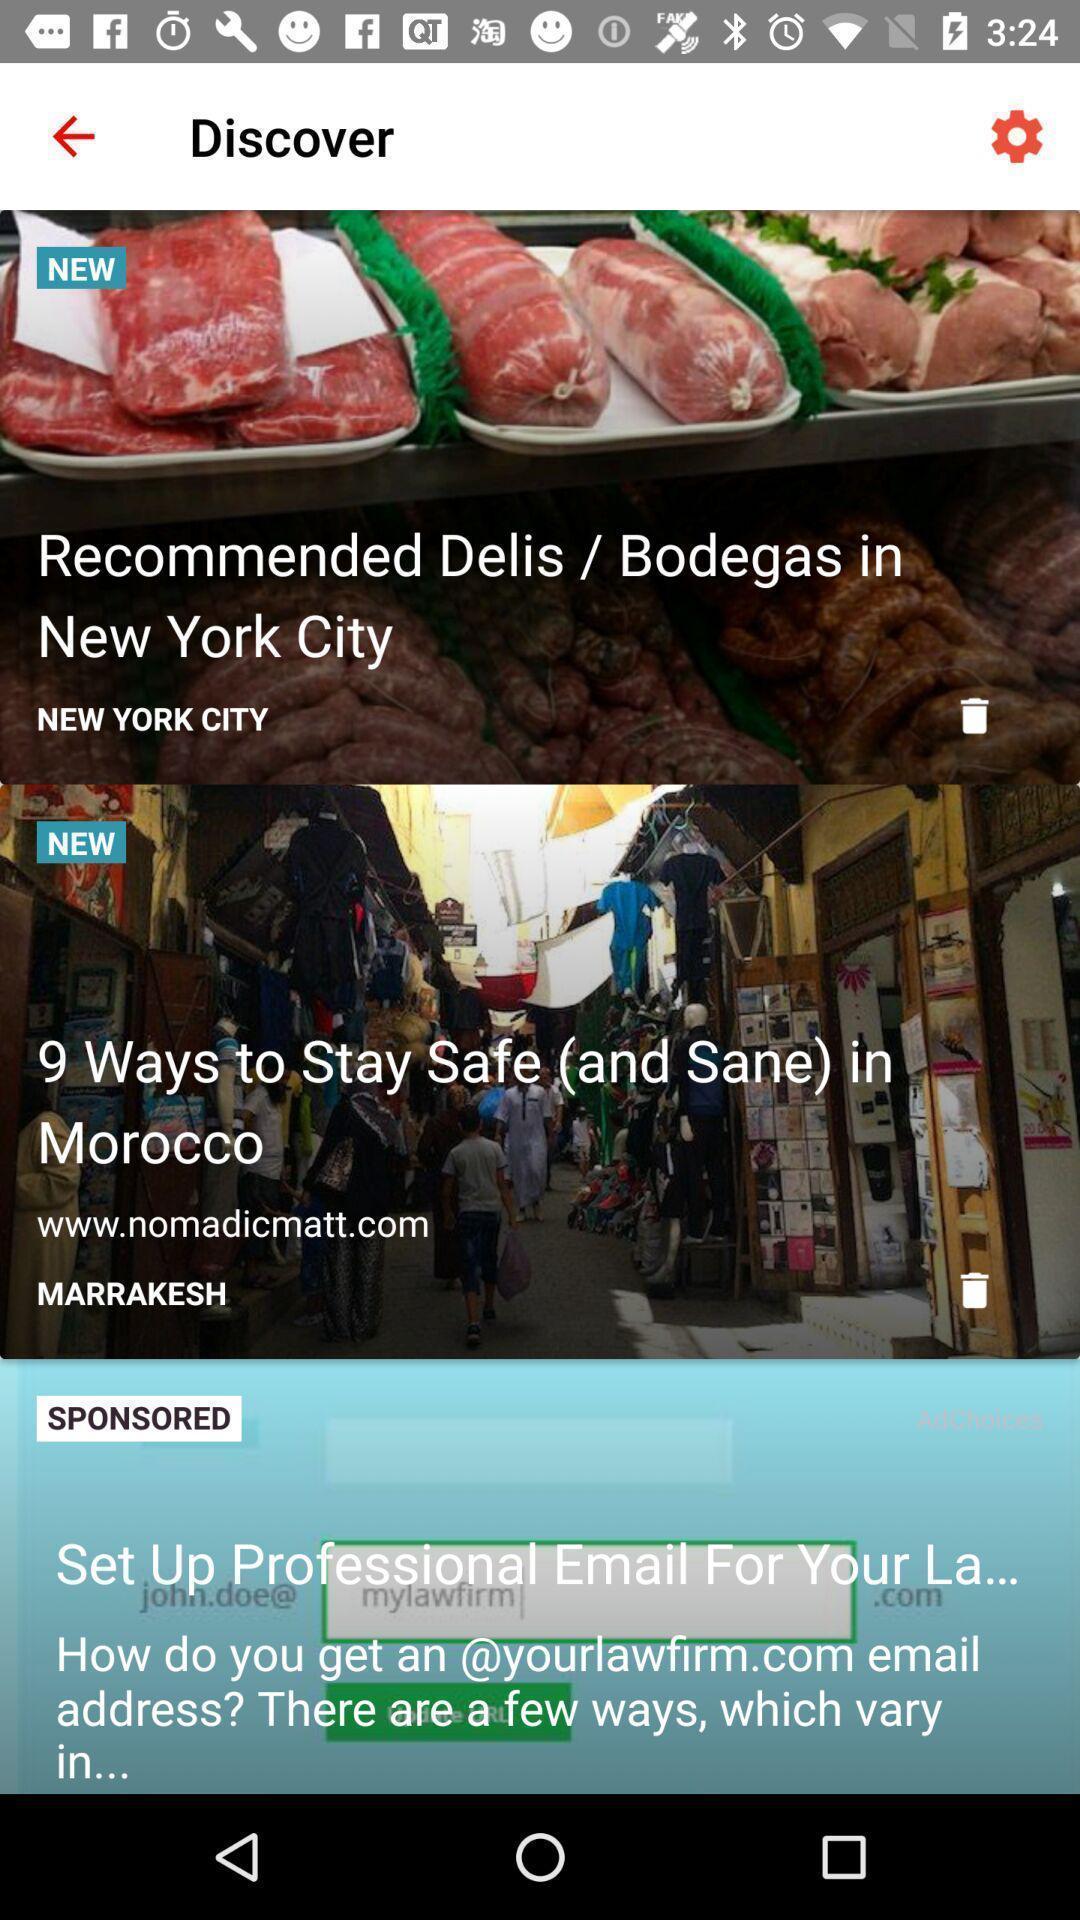Summarize the information in this screenshot. Screen shows articles in a travel app. 